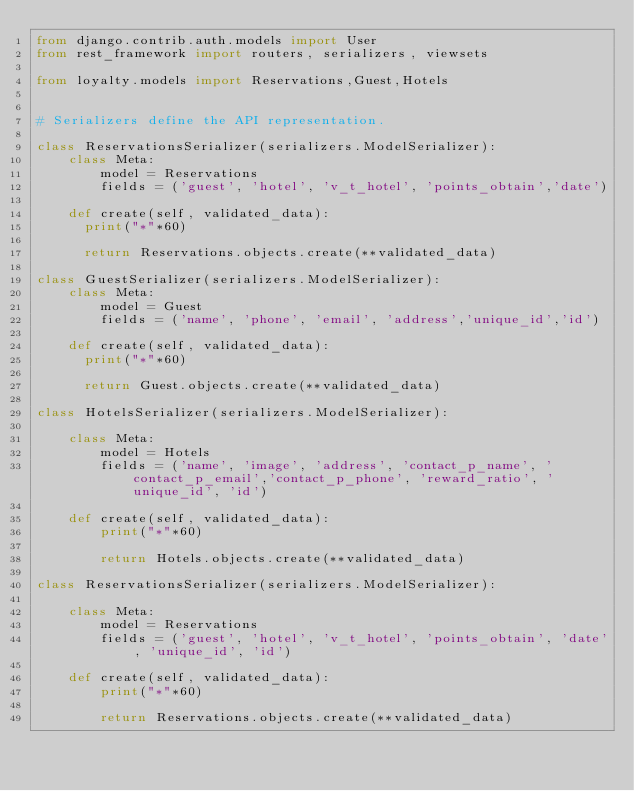<code> <loc_0><loc_0><loc_500><loc_500><_Python_>from django.contrib.auth.models import User
from rest_framework import routers, serializers, viewsets

from loyalty.models import Reservations,Guest,Hotels


# Serializers define the API representation.

class ReservationsSerializer(serializers.ModelSerializer):
    class Meta:
        model = Reservations
        fields = ('guest', 'hotel', 'v_t_hotel', 'points_obtain','date')

    def create(self, validated_data):
    	print("*"*60)

    	return Reservations.objects.create(**validated_data)
    	
class GuestSerializer(serializers.ModelSerializer):
    class Meta:
        model = Guest
        fields = ('name', 'phone', 'email', 'address','unique_id','id')

    def create(self, validated_data):
    	print("*"*60)

    	return Guest.objects.create(**validated_data)
    	
class HotelsSerializer(serializers.ModelSerializer):

    class Meta:
        model = Hotels
        fields = ('name', 'image', 'address', 'contact_p_name', 'contact_p_email','contact_p_phone', 'reward_ratio', 'unique_id', 'id')

    def create(self, validated_data):
        print("*"*60)

        return Hotels.objects.create(**validated_data)

class ReservationsSerializer(serializers.ModelSerializer):

    class Meta:
        model = Reservations
        fields = ('guest', 'hotel', 'v_t_hotel', 'points_obtain', 'date', 'unique_id', 'id')

    def create(self, validated_data):
        print("*"*60)

        return Reservations.objects.create(**validated_data)</code> 